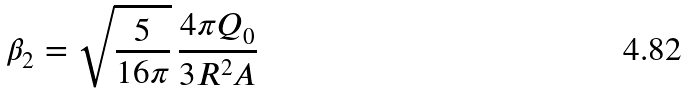Convert formula to latex. <formula><loc_0><loc_0><loc_500><loc_500>\beta _ { 2 } = \sqrt { \frac { 5 } { 1 6 \pi } } \, \frac { 4 \pi Q _ { 0 } } { 3 R ^ { 2 } A }</formula> 